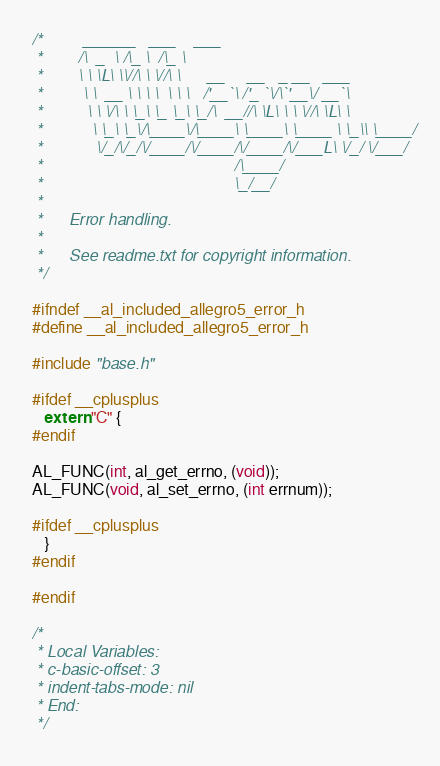<code> <loc_0><loc_0><loc_500><loc_500><_C_>/*         ______   ___    ___
 *        /\  _  \ /\_ \  /\_ \
 *        \ \ \L\ \\//\ \ \//\ \      __     __   _ __   ___
 *         \ \  __ \ \ \ \  \ \ \   /'__`\ /'_ `\/\`'__\/ __`\
 *          \ \ \/\ \ \_\ \_ \_\ \_/\  __//\ \L\ \ \ \//\ \L\ \
 *           \ \_\ \_\/\____\/\____\ \____\ \____ \ \_\\ \____/
 *            \/_/\/_/\/____/\/____/\/____/\/___L\ \/_/ \/___/
 *                                           /\____/
 *                                           \_/__/
 *
 *      Error handling.
 *
 *      See readme.txt for copyright information.
 */

#ifndef __al_included_allegro5_error_h
#define __al_included_allegro5_error_h

#include "base.h"

#ifdef __cplusplus
   extern "C" {
#endif

AL_FUNC(int, al_get_errno, (void));
AL_FUNC(void, al_set_errno, (int errnum));

#ifdef __cplusplus
   }
#endif

#endif

/*
 * Local Variables:
 * c-basic-offset: 3
 * indent-tabs-mode: nil
 * End:
 */
</code> 